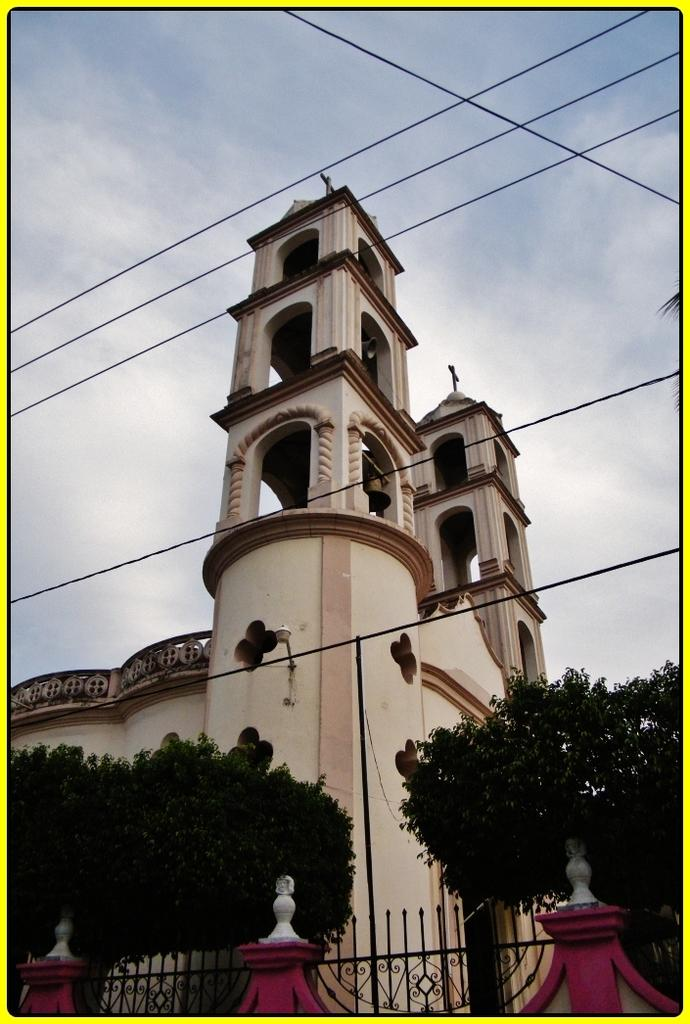What type of structure is in the image? There is a building in the image. What architectural feature can be seen on the building? The building has arches. What is located in front of the building? There are trees and railings with pillars in front of the building. What else can be seen in the image? There are wires visible in the image, and the sky is visible in the background. Can you tell me how many snakes are slithering around the building in the image? There are no snakes present in the image; the focus is on the building, trees, railings, and wires. 